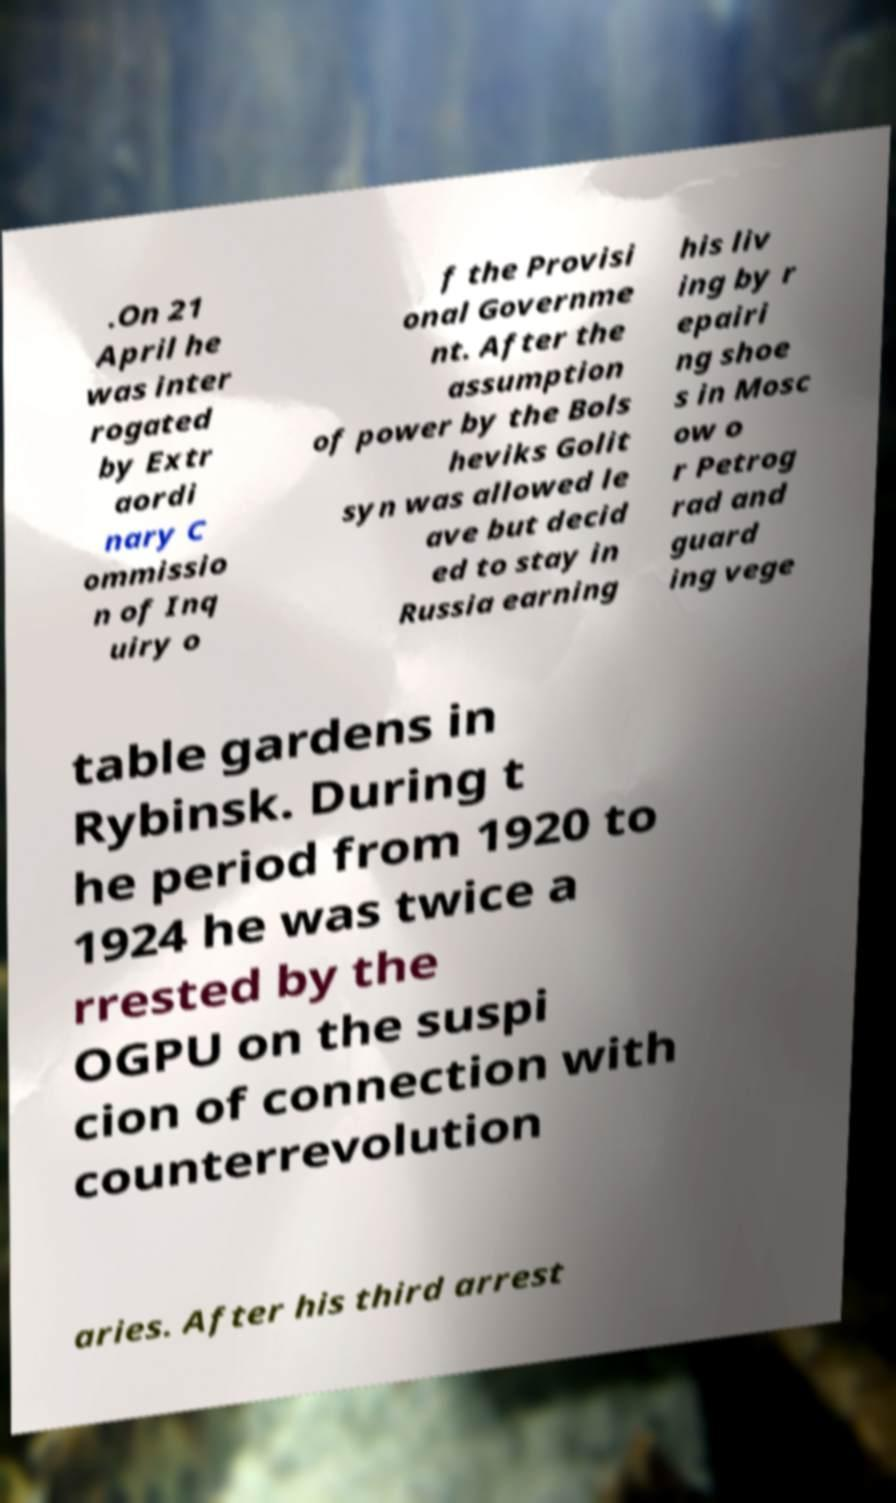There's text embedded in this image that I need extracted. Can you transcribe it verbatim? .On 21 April he was inter rogated by Extr aordi nary C ommissio n of Inq uiry o f the Provisi onal Governme nt. After the assumption of power by the Bols heviks Golit syn was allowed le ave but decid ed to stay in Russia earning his liv ing by r epairi ng shoe s in Mosc ow o r Petrog rad and guard ing vege table gardens in Rybinsk. During t he period from 1920 to 1924 he was twice a rrested by the OGPU on the suspi cion of connection with counterrevolution aries. After his third arrest 